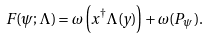Convert formula to latex. <formula><loc_0><loc_0><loc_500><loc_500>F ( \psi ; \Lambda ) = \omega \left ( x ^ { \dagger } \Lambda ( y ) \right ) + \omega ( P _ { \psi } ) .</formula> 